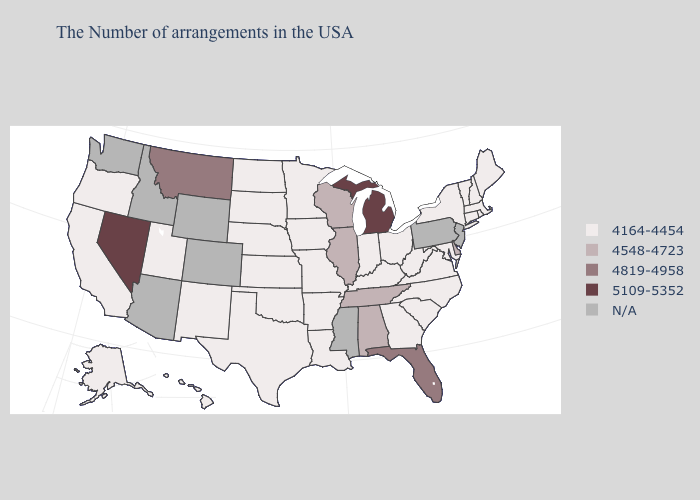Which states have the lowest value in the MidWest?
Keep it brief. Ohio, Indiana, Missouri, Minnesota, Iowa, Kansas, Nebraska, South Dakota, North Dakota. Does the first symbol in the legend represent the smallest category?
Quick response, please. Yes. What is the value of Arizona?
Give a very brief answer. N/A. What is the highest value in states that border New Mexico?
Concise answer only. 4164-4454. Does Michigan have the highest value in the USA?
Be succinct. Yes. What is the value of Louisiana?
Keep it brief. 4164-4454. What is the highest value in the USA?
Answer briefly. 5109-5352. What is the value of Delaware?
Answer briefly. 4548-4723. Does the first symbol in the legend represent the smallest category?
Answer briefly. Yes. Among the states that border Texas , which have the lowest value?
Concise answer only. Louisiana, Arkansas, Oklahoma, New Mexico. Among the states that border Mississippi , does Louisiana have the lowest value?
Short answer required. Yes. Name the states that have a value in the range 4164-4454?
Answer briefly. Maine, Massachusetts, Rhode Island, New Hampshire, Vermont, Connecticut, New York, Maryland, Virginia, North Carolina, South Carolina, West Virginia, Ohio, Georgia, Kentucky, Indiana, Louisiana, Missouri, Arkansas, Minnesota, Iowa, Kansas, Nebraska, Oklahoma, Texas, South Dakota, North Dakota, New Mexico, Utah, California, Oregon, Alaska, Hawaii. Which states have the highest value in the USA?
Be succinct. Michigan, Nevada. How many symbols are there in the legend?
Short answer required. 5. Does the map have missing data?
Concise answer only. Yes. 